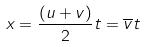<formula> <loc_0><loc_0><loc_500><loc_500>x = \frac { ( u + v ) } { 2 } t = \overline { v } t</formula> 